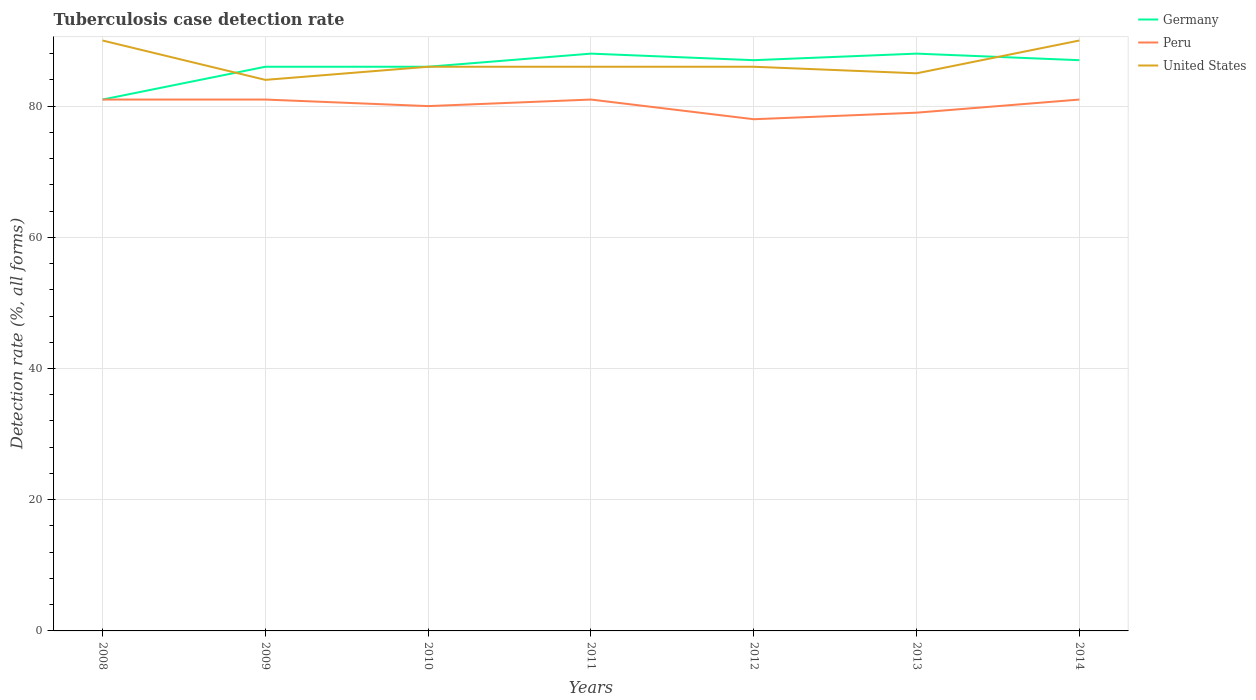Across all years, what is the maximum tuberculosis case detection rate in in Peru?
Offer a terse response. 78. In which year was the tuberculosis case detection rate in in Peru maximum?
Give a very brief answer. 2012. What is the total tuberculosis case detection rate in in Germany in the graph?
Make the answer very short. -2. What is the difference between the highest and the second highest tuberculosis case detection rate in in Peru?
Provide a short and direct response. 3. How many lines are there?
Offer a very short reply. 3. How many years are there in the graph?
Offer a very short reply. 7. Does the graph contain grids?
Offer a very short reply. Yes. Where does the legend appear in the graph?
Your answer should be compact. Top right. How many legend labels are there?
Your response must be concise. 3. What is the title of the graph?
Ensure brevity in your answer.  Tuberculosis case detection rate. What is the label or title of the X-axis?
Keep it short and to the point. Years. What is the label or title of the Y-axis?
Offer a terse response. Detection rate (%, all forms). What is the Detection rate (%, all forms) in Germany in 2008?
Make the answer very short. 81. What is the Detection rate (%, all forms) in Peru in 2008?
Offer a terse response. 81. What is the Detection rate (%, all forms) of Peru in 2010?
Ensure brevity in your answer.  80. What is the Detection rate (%, all forms) in Germany in 2011?
Your answer should be compact. 88. What is the Detection rate (%, all forms) of Peru in 2011?
Your answer should be compact. 81. What is the Detection rate (%, all forms) in Peru in 2012?
Make the answer very short. 78. What is the Detection rate (%, all forms) of United States in 2012?
Keep it short and to the point. 86. What is the Detection rate (%, all forms) of Peru in 2013?
Offer a terse response. 79. What is the Detection rate (%, all forms) in United States in 2013?
Your response must be concise. 85. What is the Detection rate (%, all forms) in Germany in 2014?
Make the answer very short. 87. What is the Detection rate (%, all forms) in Peru in 2014?
Provide a succinct answer. 81. Across all years, what is the maximum Detection rate (%, all forms) in United States?
Your response must be concise. 90. Across all years, what is the minimum Detection rate (%, all forms) of United States?
Provide a succinct answer. 84. What is the total Detection rate (%, all forms) in Germany in the graph?
Your answer should be compact. 603. What is the total Detection rate (%, all forms) in Peru in the graph?
Offer a terse response. 561. What is the total Detection rate (%, all forms) of United States in the graph?
Your answer should be very brief. 607. What is the difference between the Detection rate (%, all forms) of United States in 2008 and that in 2009?
Offer a very short reply. 6. What is the difference between the Detection rate (%, all forms) in Germany in 2008 and that in 2010?
Ensure brevity in your answer.  -5. What is the difference between the Detection rate (%, all forms) of Peru in 2008 and that in 2010?
Keep it short and to the point. 1. What is the difference between the Detection rate (%, all forms) in United States in 2008 and that in 2010?
Offer a terse response. 4. What is the difference between the Detection rate (%, all forms) in Germany in 2008 and that in 2011?
Give a very brief answer. -7. What is the difference between the Detection rate (%, all forms) of United States in 2008 and that in 2013?
Make the answer very short. 5. What is the difference between the Detection rate (%, all forms) of Germany in 2009 and that in 2010?
Ensure brevity in your answer.  0. What is the difference between the Detection rate (%, all forms) of Peru in 2009 and that in 2010?
Your answer should be very brief. 1. What is the difference between the Detection rate (%, all forms) of Peru in 2009 and that in 2011?
Provide a short and direct response. 0. What is the difference between the Detection rate (%, all forms) of United States in 2009 and that in 2012?
Your response must be concise. -2. What is the difference between the Detection rate (%, all forms) of United States in 2009 and that in 2013?
Ensure brevity in your answer.  -1. What is the difference between the Detection rate (%, all forms) of Germany in 2010 and that in 2011?
Your answer should be very brief. -2. What is the difference between the Detection rate (%, all forms) of Peru in 2010 and that in 2011?
Provide a short and direct response. -1. What is the difference between the Detection rate (%, all forms) in Peru in 2010 and that in 2013?
Provide a short and direct response. 1. What is the difference between the Detection rate (%, all forms) of Peru in 2010 and that in 2014?
Give a very brief answer. -1. What is the difference between the Detection rate (%, all forms) of United States in 2011 and that in 2012?
Your answer should be very brief. 0. What is the difference between the Detection rate (%, all forms) in Germany in 2011 and that in 2013?
Keep it short and to the point. 0. What is the difference between the Detection rate (%, all forms) in United States in 2011 and that in 2013?
Your response must be concise. 1. What is the difference between the Detection rate (%, all forms) of United States in 2011 and that in 2014?
Ensure brevity in your answer.  -4. What is the difference between the Detection rate (%, all forms) in Peru in 2012 and that in 2013?
Your response must be concise. -1. What is the difference between the Detection rate (%, all forms) in Germany in 2012 and that in 2014?
Provide a short and direct response. 0. What is the difference between the Detection rate (%, all forms) in United States in 2012 and that in 2014?
Your answer should be compact. -4. What is the difference between the Detection rate (%, all forms) of Peru in 2013 and that in 2014?
Keep it short and to the point. -2. What is the difference between the Detection rate (%, all forms) of United States in 2013 and that in 2014?
Make the answer very short. -5. What is the difference between the Detection rate (%, all forms) in Germany in 2008 and the Detection rate (%, all forms) in Peru in 2010?
Give a very brief answer. 1. What is the difference between the Detection rate (%, all forms) of Germany in 2008 and the Detection rate (%, all forms) of Peru in 2011?
Keep it short and to the point. 0. What is the difference between the Detection rate (%, all forms) in Germany in 2008 and the Detection rate (%, all forms) in United States in 2011?
Provide a short and direct response. -5. What is the difference between the Detection rate (%, all forms) of Peru in 2008 and the Detection rate (%, all forms) of United States in 2011?
Ensure brevity in your answer.  -5. What is the difference between the Detection rate (%, all forms) in Germany in 2008 and the Detection rate (%, all forms) in Peru in 2012?
Your answer should be very brief. 3. What is the difference between the Detection rate (%, all forms) in Germany in 2008 and the Detection rate (%, all forms) in Peru in 2013?
Provide a succinct answer. 2. What is the difference between the Detection rate (%, all forms) of Germany in 2008 and the Detection rate (%, all forms) of United States in 2013?
Give a very brief answer. -4. What is the difference between the Detection rate (%, all forms) in Peru in 2008 and the Detection rate (%, all forms) in United States in 2013?
Provide a succinct answer. -4. What is the difference between the Detection rate (%, all forms) of Peru in 2008 and the Detection rate (%, all forms) of United States in 2014?
Your answer should be compact. -9. What is the difference between the Detection rate (%, all forms) in Germany in 2009 and the Detection rate (%, all forms) in United States in 2010?
Offer a terse response. 0. What is the difference between the Detection rate (%, all forms) in Peru in 2009 and the Detection rate (%, all forms) in United States in 2010?
Ensure brevity in your answer.  -5. What is the difference between the Detection rate (%, all forms) in Germany in 2009 and the Detection rate (%, all forms) in Peru in 2011?
Offer a very short reply. 5. What is the difference between the Detection rate (%, all forms) of Peru in 2009 and the Detection rate (%, all forms) of United States in 2011?
Make the answer very short. -5. What is the difference between the Detection rate (%, all forms) of Germany in 2009 and the Detection rate (%, all forms) of Peru in 2012?
Give a very brief answer. 8. What is the difference between the Detection rate (%, all forms) in Germany in 2009 and the Detection rate (%, all forms) in United States in 2012?
Your answer should be compact. 0. What is the difference between the Detection rate (%, all forms) of Peru in 2009 and the Detection rate (%, all forms) of United States in 2012?
Give a very brief answer. -5. What is the difference between the Detection rate (%, all forms) of Germany in 2009 and the Detection rate (%, all forms) of United States in 2014?
Offer a very short reply. -4. What is the difference between the Detection rate (%, all forms) in Peru in 2009 and the Detection rate (%, all forms) in United States in 2014?
Provide a short and direct response. -9. What is the difference between the Detection rate (%, all forms) in Peru in 2010 and the Detection rate (%, all forms) in United States in 2011?
Provide a short and direct response. -6. What is the difference between the Detection rate (%, all forms) of Germany in 2010 and the Detection rate (%, all forms) of Peru in 2012?
Your answer should be compact. 8. What is the difference between the Detection rate (%, all forms) in Germany in 2010 and the Detection rate (%, all forms) in United States in 2013?
Ensure brevity in your answer.  1. What is the difference between the Detection rate (%, all forms) in Peru in 2010 and the Detection rate (%, all forms) in United States in 2013?
Give a very brief answer. -5. What is the difference between the Detection rate (%, all forms) of Germany in 2010 and the Detection rate (%, all forms) of United States in 2014?
Ensure brevity in your answer.  -4. What is the difference between the Detection rate (%, all forms) in Germany in 2011 and the Detection rate (%, all forms) in United States in 2012?
Your response must be concise. 2. What is the difference between the Detection rate (%, all forms) of Peru in 2011 and the Detection rate (%, all forms) of United States in 2013?
Your response must be concise. -4. What is the difference between the Detection rate (%, all forms) in Germany in 2011 and the Detection rate (%, all forms) in United States in 2014?
Give a very brief answer. -2. What is the difference between the Detection rate (%, all forms) of Peru in 2011 and the Detection rate (%, all forms) of United States in 2014?
Keep it short and to the point. -9. What is the difference between the Detection rate (%, all forms) of Germany in 2012 and the Detection rate (%, all forms) of United States in 2013?
Give a very brief answer. 2. What is the difference between the Detection rate (%, all forms) in Peru in 2012 and the Detection rate (%, all forms) in United States in 2013?
Provide a short and direct response. -7. What is the difference between the Detection rate (%, all forms) in Germany in 2012 and the Detection rate (%, all forms) in Peru in 2014?
Your answer should be compact. 6. What is the difference between the Detection rate (%, all forms) of Germany in 2012 and the Detection rate (%, all forms) of United States in 2014?
Your response must be concise. -3. What is the difference between the Detection rate (%, all forms) of Germany in 2013 and the Detection rate (%, all forms) of Peru in 2014?
Offer a terse response. 7. What is the difference between the Detection rate (%, all forms) in Peru in 2013 and the Detection rate (%, all forms) in United States in 2014?
Provide a short and direct response. -11. What is the average Detection rate (%, all forms) in Germany per year?
Offer a very short reply. 86.14. What is the average Detection rate (%, all forms) in Peru per year?
Your answer should be compact. 80.14. What is the average Detection rate (%, all forms) in United States per year?
Offer a terse response. 86.71. In the year 2009, what is the difference between the Detection rate (%, all forms) of Germany and Detection rate (%, all forms) of United States?
Keep it short and to the point. 2. In the year 2009, what is the difference between the Detection rate (%, all forms) of Peru and Detection rate (%, all forms) of United States?
Provide a short and direct response. -3. In the year 2010, what is the difference between the Detection rate (%, all forms) in Germany and Detection rate (%, all forms) in Peru?
Keep it short and to the point. 6. In the year 2010, what is the difference between the Detection rate (%, all forms) in Germany and Detection rate (%, all forms) in United States?
Provide a succinct answer. 0. In the year 2010, what is the difference between the Detection rate (%, all forms) in Peru and Detection rate (%, all forms) in United States?
Your answer should be compact. -6. In the year 2011, what is the difference between the Detection rate (%, all forms) of Germany and Detection rate (%, all forms) of Peru?
Your response must be concise. 7. In the year 2011, what is the difference between the Detection rate (%, all forms) of Germany and Detection rate (%, all forms) of United States?
Your answer should be very brief. 2. In the year 2011, what is the difference between the Detection rate (%, all forms) of Peru and Detection rate (%, all forms) of United States?
Offer a very short reply. -5. In the year 2013, what is the difference between the Detection rate (%, all forms) in Germany and Detection rate (%, all forms) in Peru?
Your answer should be very brief. 9. In the year 2013, what is the difference between the Detection rate (%, all forms) in Germany and Detection rate (%, all forms) in United States?
Your response must be concise. 3. In the year 2014, what is the difference between the Detection rate (%, all forms) in Germany and Detection rate (%, all forms) in Peru?
Make the answer very short. 6. In the year 2014, what is the difference between the Detection rate (%, all forms) in Peru and Detection rate (%, all forms) in United States?
Make the answer very short. -9. What is the ratio of the Detection rate (%, all forms) of Germany in 2008 to that in 2009?
Offer a terse response. 0.94. What is the ratio of the Detection rate (%, all forms) of Peru in 2008 to that in 2009?
Make the answer very short. 1. What is the ratio of the Detection rate (%, all forms) of United States in 2008 to that in 2009?
Your answer should be very brief. 1.07. What is the ratio of the Detection rate (%, all forms) in Germany in 2008 to that in 2010?
Give a very brief answer. 0.94. What is the ratio of the Detection rate (%, all forms) in Peru in 2008 to that in 2010?
Offer a very short reply. 1.01. What is the ratio of the Detection rate (%, all forms) in United States in 2008 to that in 2010?
Ensure brevity in your answer.  1.05. What is the ratio of the Detection rate (%, all forms) of Germany in 2008 to that in 2011?
Your answer should be very brief. 0.92. What is the ratio of the Detection rate (%, all forms) in Peru in 2008 to that in 2011?
Ensure brevity in your answer.  1. What is the ratio of the Detection rate (%, all forms) in United States in 2008 to that in 2011?
Your response must be concise. 1.05. What is the ratio of the Detection rate (%, all forms) of Peru in 2008 to that in 2012?
Provide a succinct answer. 1.04. What is the ratio of the Detection rate (%, all forms) of United States in 2008 to that in 2012?
Ensure brevity in your answer.  1.05. What is the ratio of the Detection rate (%, all forms) of Germany in 2008 to that in 2013?
Offer a terse response. 0.92. What is the ratio of the Detection rate (%, all forms) of Peru in 2008 to that in 2013?
Provide a succinct answer. 1.03. What is the ratio of the Detection rate (%, all forms) of United States in 2008 to that in 2013?
Make the answer very short. 1.06. What is the ratio of the Detection rate (%, all forms) in United States in 2008 to that in 2014?
Ensure brevity in your answer.  1. What is the ratio of the Detection rate (%, all forms) of Germany in 2009 to that in 2010?
Ensure brevity in your answer.  1. What is the ratio of the Detection rate (%, all forms) of Peru in 2009 to that in 2010?
Your answer should be compact. 1.01. What is the ratio of the Detection rate (%, all forms) in United States in 2009 to that in 2010?
Provide a succinct answer. 0.98. What is the ratio of the Detection rate (%, all forms) of Germany in 2009 to that in 2011?
Your answer should be compact. 0.98. What is the ratio of the Detection rate (%, all forms) in Peru in 2009 to that in 2011?
Your answer should be compact. 1. What is the ratio of the Detection rate (%, all forms) in United States in 2009 to that in 2011?
Give a very brief answer. 0.98. What is the ratio of the Detection rate (%, all forms) of United States in 2009 to that in 2012?
Your answer should be very brief. 0.98. What is the ratio of the Detection rate (%, all forms) in Germany in 2009 to that in 2013?
Keep it short and to the point. 0.98. What is the ratio of the Detection rate (%, all forms) in Peru in 2009 to that in 2013?
Your response must be concise. 1.03. What is the ratio of the Detection rate (%, all forms) of United States in 2009 to that in 2013?
Offer a very short reply. 0.99. What is the ratio of the Detection rate (%, all forms) of Germany in 2009 to that in 2014?
Make the answer very short. 0.99. What is the ratio of the Detection rate (%, all forms) in Peru in 2009 to that in 2014?
Provide a succinct answer. 1. What is the ratio of the Detection rate (%, all forms) of Germany in 2010 to that in 2011?
Offer a very short reply. 0.98. What is the ratio of the Detection rate (%, all forms) in United States in 2010 to that in 2011?
Your answer should be compact. 1. What is the ratio of the Detection rate (%, all forms) in Germany in 2010 to that in 2012?
Your answer should be very brief. 0.99. What is the ratio of the Detection rate (%, all forms) in Peru in 2010 to that in 2012?
Keep it short and to the point. 1.03. What is the ratio of the Detection rate (%, all forms) in United States in 2010 to that in 2012?
Give a very brief answer. 1. What is the ratio of the Detection rate (%, all forms) of Germany in 2010 to that in 2013?
Offer a terse response. 0.98. What is the ratio of the Detection rate (%, all forms) of Peru in 2010 to that in 2013?
Provide a short and direct response. 1.01. What is the ratio of the Detection rate (%, all forms) of United States in 2010 to that in 2013?
Offer a very short reply. 1.01. What is the ratio of the Detection rate (%, all forms) of Germany in 2010 to that in 2014?
Offer a terse response. 0.99. What is the ratio of the Detection rate (%, all forms) of United States in 2010 to that in 2014?
Your answer should be very brief. 0.96. What is the ratio of the Detection rate (%, all forms) of Germany in 2011 to that in 2012?
Your answer should be very brief. 1.01. What is the ratio of the Detection rate (%, all forms) of Peru in 2011 to that in 2012?
Your answer should be very brief. 1.04. What is the ratio of the Detection rate (%, all forms) in Peru in 2011 to that in 2013?
Offer a terse response. 1.03. What is the ratio of the Detection rate (%, all forms) in United States in 2011 to that in 2013?
Your response must be concise. 1.01. What is the ratio of the Detection rate (%, all forms) of Germany in 2011 to that in 2014?
Provide a short and direct response. 1.01. What is the ratio of the Detection rate (%, all forms) of Peru in 2011 to that in 2014?
Ensure brevity in your answer.  1. What is the ratio of the Detection rate (%, all forms) in United States in 2011 to that in 2014?
Make the answer very short. 0.96. What is the ratio of the Detection rate (%, all forms) of Peru in 2012 to that in 2013?
Offer a terse response. 0.99. What is the ratio of the Detection rate (%, all forms) of United States in 2012 to that in 2013?
Give a very brief answer. 1.01. What is the ratio of the Detection rate (%, all forms) of Peru in 2012 to that in 2014?
Keep it short and to the point. 0.96. What is the ratio of the Detection rate (%, all forms) of United States in 2012 to that in 2014?
Your answer should be compact. 0.96. What is the ratio of the Detection rate (%, all forms) in Germany in 2013 to that in 2014?
Offer a terse response. 1.01. What is the ratio of the Detection rate (%, all forms) in Peru in 2013 to that in 2014?
Offer a very short reply. 0.98. What is the difference between the highest and the second highest Detection rate (%, all forms) in Germany?
Keep it short and to the point. 0. What is the difference between the highest and the second highest Detection rate (%, all forms) of Peru?
Your answer should be compact. 0. What is the difference between the highest and the lowest Detection rate (%, all forms) of Germany?
Keep it short and to the point. 7. What is the difference between the highest and the lowest Detection rate (%, all forms) in United States?
Keep it short and to the point. 6. 